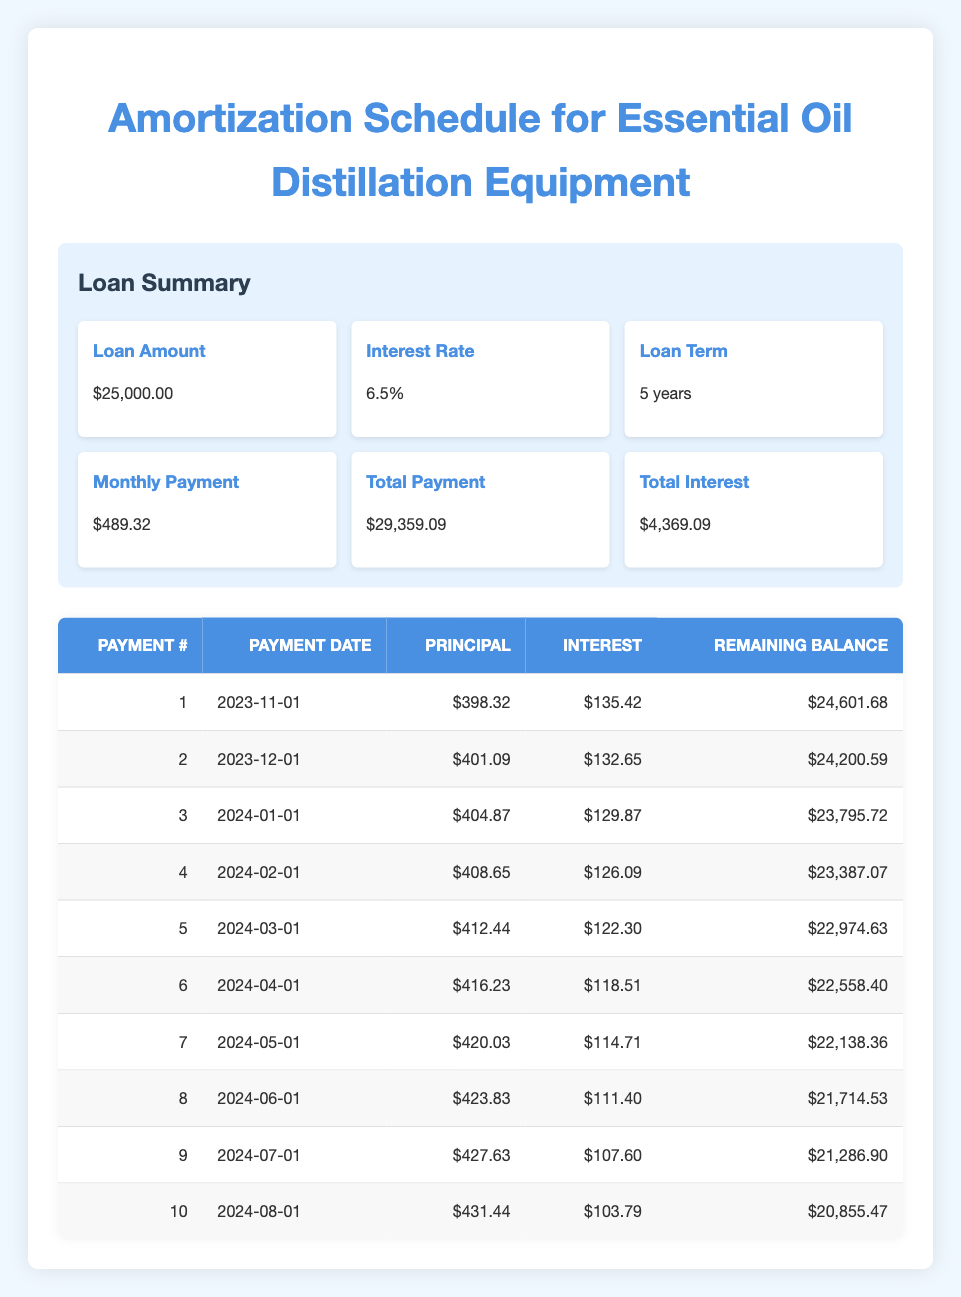What is the total amount of interest paid over the life of the loan? The total interest paid is provided in the summary section of the table, which states that the total interest is 4,369.09.
Answer: 4,369.09 How much is the principal payment for the second payment date? The principal payment for the second payment date (2023-12-01) is listed in the schedule as 401.09.
Answer: 401.09 Is the interest payment for the first month greater than the interest payment for the fourth month? The interest payment for the first month is 135.42, while the interest payment for the fourth month is 126.09. Since 135.42 is greater than 126.09, the answer is yes.
Answer: Yes What is the total of the principal payments for the first five months? To find the total, sum the principal payments for the first five months: 398.32 + 401.09 + 404.87 + 408.65 + 412.44 = 2025.37.
Answer: 2025.37 What is the remaining balance after the third payment? The remaining balance after the third payment (2024-01-01) is given in the schedule as 23,795.72.
Answer: 23,795.72 If the total payment over the life of the loan is 29,359.09, what is the monthly payment? The monthly payment is also stated in the summary section to be 489.32. This can be checked by dividing the total payment by the number of payments (5 years * 12 months = 60 months). 29,359.09 / 60 = 489.32.
Answer: 489.32 How much did the principal decrease in the seventh payment compared to the sixth payment? The principal payment for the seventh payment is 420.03 and for the sixth payment is 416.23. To find the difference: 420.03 - 416.23 = 3.80.
Answer: 3.80 What is the average monthly payment over the five-year term of the loan? Since the monthly payment is fixed at 489.32, the average monthly payment is also 489.32 regardless of how many payments were made.
Answer: 489.32 What is the total remaining balance after the tenth payment? The remaining balance after the tenth payment (2024-08-01) is found in the schedule and is 20,855.47.
Answer: 20,855.47 